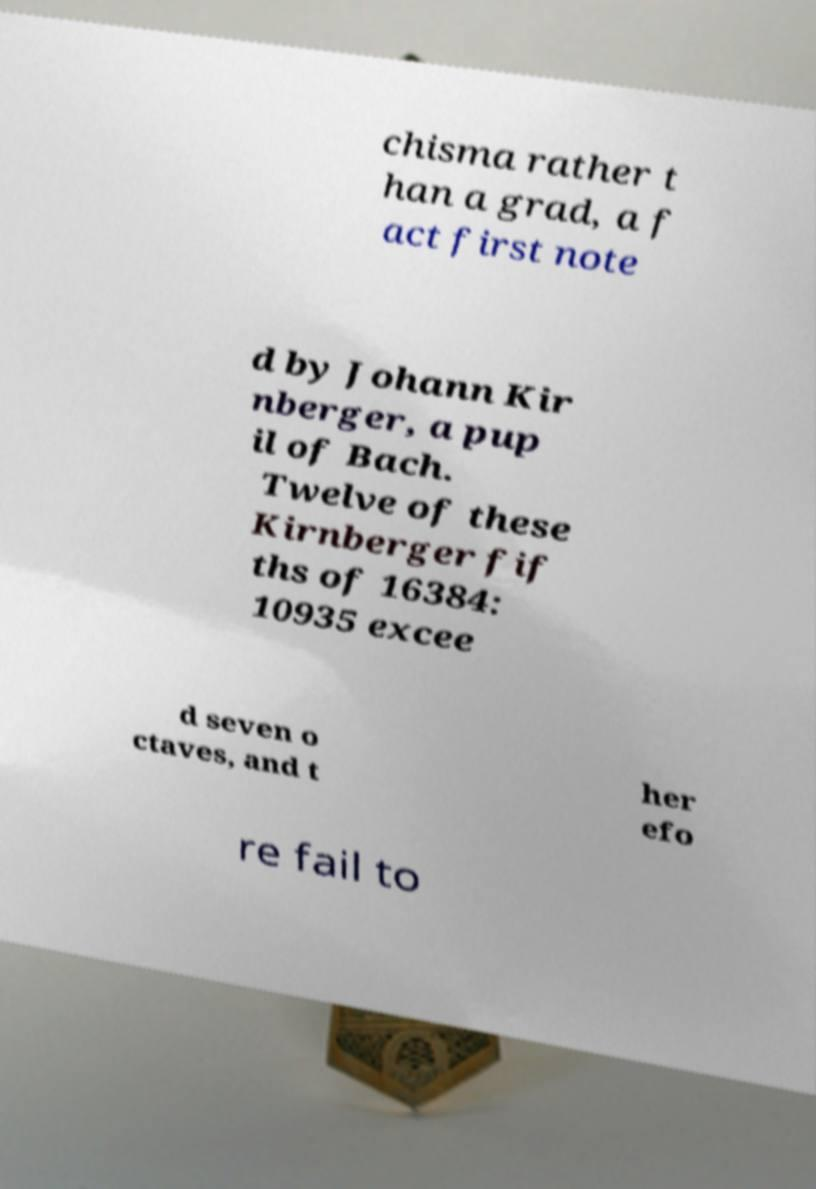For documentation purposes, I need the text within this image transcribed. Could you provide that? chisma rather t han a grad, a f act first note d by Johann Kir nberger, a pup il of Bach. Twelve of these Kirnberger fif ths of 16384: 10935 excee d seven o ctaves, and t her efo re fail to 